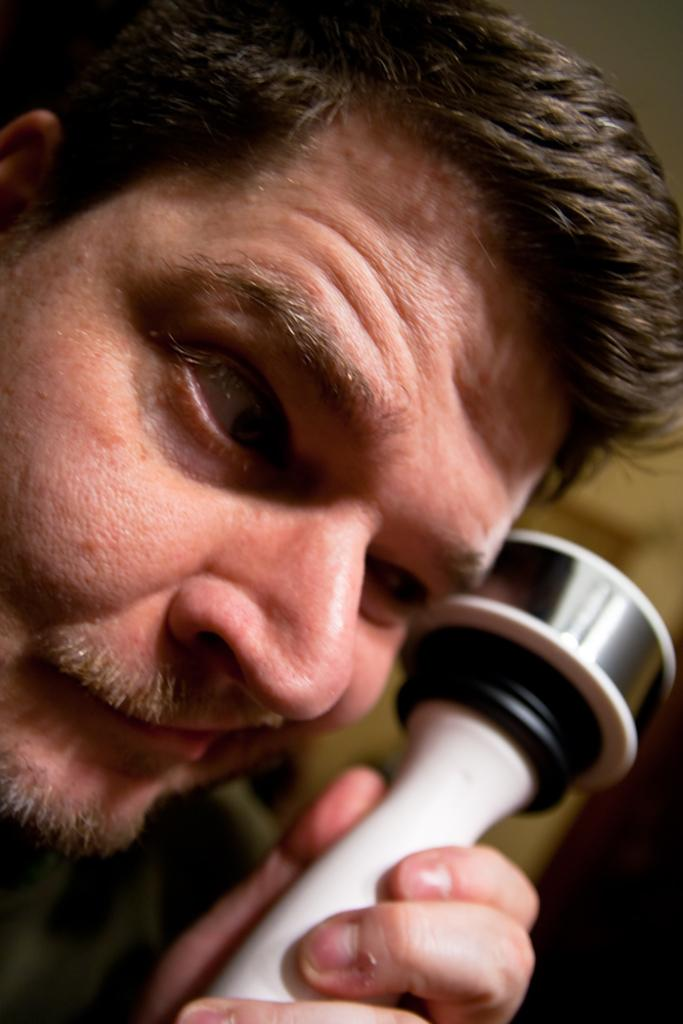Who is present in the image? There is a man in the image. What is the man doing in the image? The man is holding an object. Can you describe the background of the image? The background of the image is blurred. How many dolls can be seen in the image? There are no dolls present in the image. What hope does the man have for the future in the image? The image does not provide any information about the man's hopes for the future. 